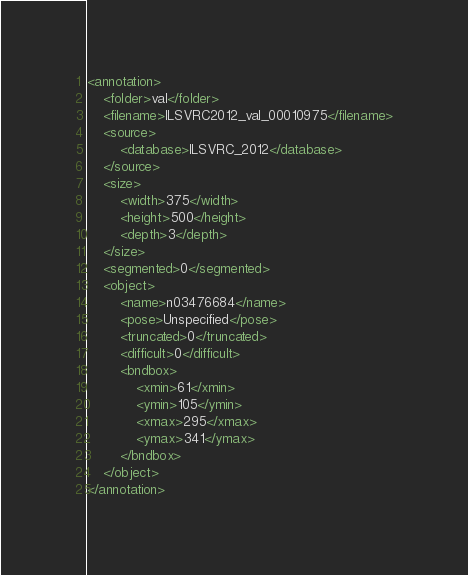<code> <loc_0><loc_0><loc_500><loc_500><_XML_><annotation>
	<folder>val</folder>
	<filename>ILSVRC2012_val_00010975</filename>
	<source>
		<database>ILSVRC_2012</database>
	</source>
	<size>
		<width>375</width>
		<height>500</height>
		<depth>3</depth>
	</size>
	<segmented>0</segmented>
	<object>
		<name>n03476684</name>
		<pose>Unspecified</pose>
		<truncated>0</truncated>
		<difficult>0</difficult>
		<bndbox>
			<xmin>61</xmin>
			<ymin>105</ymin>
			<xmax>295</xmax>
			<ymax>341</ymax>
		</bndbox>
	</object>
</annotation></code> 